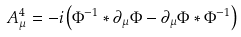<formula> <loc_0><loc_0><loc_500><loc_500>A _ { \mu } ^ { 4 } = - i \left ( \Phi ^ { - 1 } * \partial _ { \mu } \Phi - \partial _ { \mu } \Phi * \Phi ^ { - 1 } \right )</formula> 